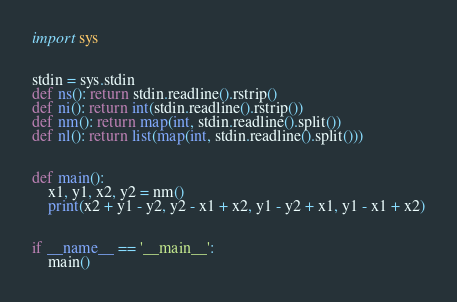Convert code to text. <code><loc_0><loc_0><loc_500><loc_500><_Python_>import sys


stdin = sys.stdin
def ns(): return stdin.readline().rstrip()
def ni(): return int(stdin.readline().rstrip())
def nm(): return map(int, stdin.readline().split())
def nl(): return list(map(int, stdin.readline().split()))


def main():
    x1, y1, x2, y2 = nm()
    print(x2 + y1 - y2, y2 - x1 + x2, y1 - y2 + x1, y1 - x1 + x2)


if __name__ == '__main__':
    main()
</code> 